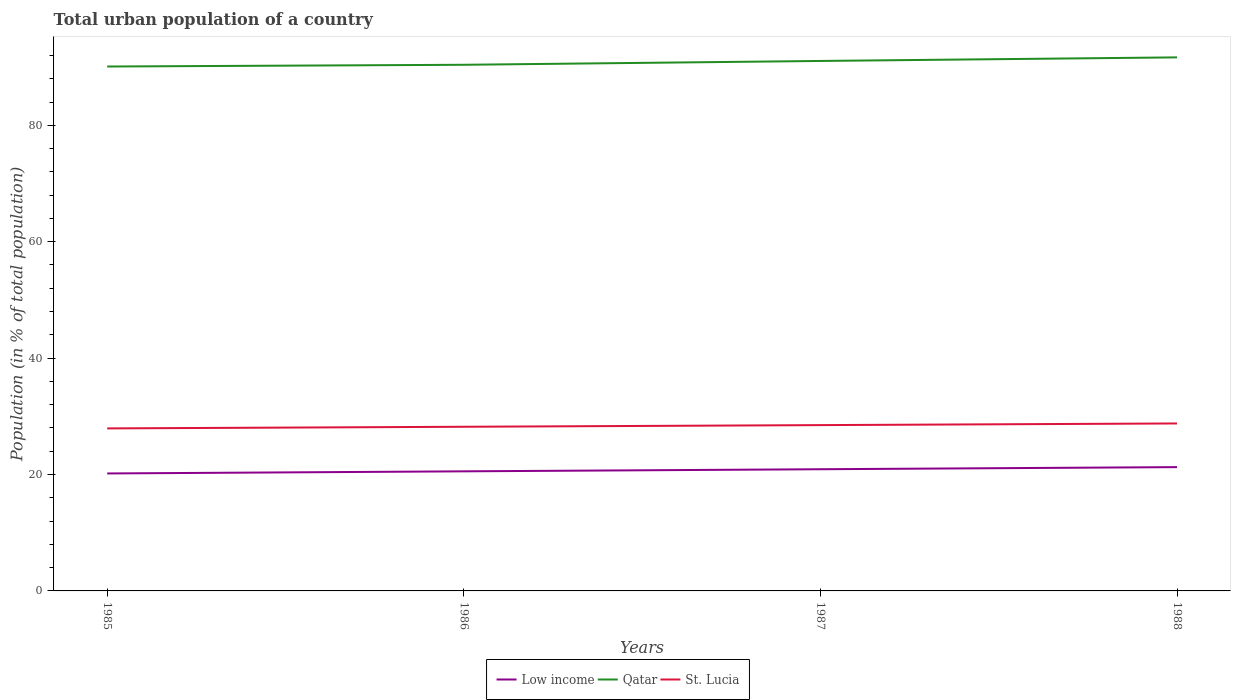Is the number of lines equal to the number of legend labels?
Offer a very short reply. Yes. Across all years, what is the maximum urban population in St. Lucia?
Ensure brevity in your answer.  27.92. What is the total urban population in St. Lucia in the graph?
Keep it short and to the point. -0.57. What is the difference between the highest and the second highest urban population in Qatar?
Keep it short and to the point. 1.57. Is the urban population in Low income strictly greater than the urban population in St. Lucia over the years?
Your answer should be very brief. Yes. How many lines are there?
Your answer should be very brief. 3. What is the difference between two consecutive major ticks on the Y-axis?
Provide a succinct answer. 20. Are the values on the major ticks of Y-axis written in scientific E-notation?
Keep it short and to the point. No. Does the graph contain any zero values?
Your answer should be very brief. No. Does the graph contain grids?
Make the answer very short. No. How many legend labels are there?
Give a very brief answer. 3. What is the title of the graph?
Offer a very short reply. Total urban population of a country. Does "St. Martin (French part)" appear as one of the legend labels in the graph?
Your answer should be very brief. No. What is the label or title of the X-axis?
Offer a very short reply. Years. What is the label or title of the Y-axis?
Provide a short and direct response. Population (in % of total population). What is the Population (in % of total population) of Low income in 1985?
Give a very brief answer. 20.18. What is the Population (in % of total population) of Qatar in 1985?
Your answer should be very brief. 90.1. What is the Population (in % of total population) of St. Lucia in 1985?
Keep it short and to the point. 27.92. What is the Population (in % of total population) of Low income in 1986?
Your response must be concise. 20.55. What is the Population (in % of total population) of Qatar in 1986?
Your answer should be compact. 90.4. What is the Population (in % of total population) in St. Lucia in 1986?
Provide a short and direct response. 28.2. What is the Population (in % of total population) in Low income in 1987?
Make the answer very short. 20.91. What is the Population (in % of total population) of Qatar in 1987?
Your response must be concise. 91.06. What is the Population (in % of total population) in St. Lucia in 1987?
Keep it short and to the point. 28.49. What is the Population (in % of total population) in Low income in 1988?
Offer a terse response. 21.27. What is the Population (in % of total population) in Qatar in 1988?
Offer a terse response. 91.67. What is the Population (in % of total population) in St. Lucia in 1988?
Your answer should be compact. 28.77. Across all years, what is the maximum Population (in % of total population) of Low income?
Make the answer very short. 21.27. Across all years, what is the maximum Population (in % of total population) of Qatar?
Provide a short and direct response. 91.67. Across all years, what is the maximum Population (in % of total population) of St. Lucia?
Provide a short and direct response. 28.77. Across all years, what is the minimum Population (in % of total population) of Low income?
Offer a terse response. 20.18. Across all years, what is the minimum Population (in % of total population) of Qatar?
Offer a terse response. 90.1. Across all years, what is the minimum Population (in % of total population) of St. Lucia?
Give a very brief answer. 27.92. What is the total Population (in % of total population) in Low income in the graph?
Make the answer very short. 82.91. What is the total Population (in % of total population) in Qatar in the graph?
Offer a very short reply. 363.23. What is the total Population (in % of total population) of St. Lucia in the graph?
Make the answer very short. 113.39. What is the difference between the Population (in % of total population) in Low income in 1985 and that in 1986?
Give a very brief answer. -0.37. What is the difference between the Population (in % of total population) in St. Lucia in 1985 and that in 1986?
Your answer should be very brief. -0.28. What is the difference between the Population (in % of total population) of Low income in 1985 and that in 1987?
Make the answer very short. -0.72. What is the difference between the Population (in % of total population) of Qatar in 1985 and that in 1987?
Offer a very short reply. -0.96. What is the difference between the Population (in % of total population) of St. Lucia in 1985 and that in 1987?
Ensure brevity in your answer.  -0.56. What is the difference between the Population (in % of total population) in Low income in 1985 and that in 1988?
Ensure brevity in your answer.  -1.09. What is the difference between the Population (in % of total population) of Qatar in 1985 and that in 1988?
Your answer should be very brief. -1.57. What is the difference between the Population (in % of total population) in St. Lucia in 1985 and that in 1988?
Offer a terse response. -0.85. What is the difference between the Population (in % of total population) of Low income in 1986 and that in 1987?
Ensure brevity in your answer.  -0.36. What is the difference between the Population (in % of total population) in Qatar in 1986 and that in 1987?
Your answer should be compact. -0.66. What is the difference between the Population (in % of total population) of St. Lucia in 1986 and that in 1987?
Your response must be concise. -0.28. What is the difference between the Population (in % of total population) in Low income in 1986 and that in 1988?
Give a very brief answer. -0.72. What is the difference between the Population (in % of total population) of Qatar in 1986 and that in 1988?
Your answer should be very brief. -1.27. What is the difference between the Population (in % of total population) in St. Lucia in 1986 and that in 1988?
Make the answer very short. -0.57. What is the difference between the Population (in % of total population) of Low income in 1987 and that in 1988?
Keep it short and to the point. -0.36. What is the difference between the Population (in % of total population) of Qatar in 1987 and that in 1988?
Offer a terse response. -0.61. What is the difference between the Population (in % of total population) in St. Lucia in 1987 and that in 1988?
Give a very brief answer. -0.29. What is the difference between the Population (in % of total population) of Low income in 1985 and the Population (in % of total population) of Qatar in 1986?
Keep it short and to the point. -70.22. What is the difference between the Population (in % of total population) in Low income in 1985 and the Population (in % of total population) in St. Lucia in 1986?
Your response must be concise. -8.02. What is the difference between the Population (in % of total population) of Qatar in 1985 and the Population (in % of total population) of St. Lucia in 1986?
Your answer should be compact. 61.9. What is the difference between the Population (in % of total population) of Low income in 1985 and the Population (in % of total population) of Qatar in 1987?
Provide a succinct answer. -70.87. What is the difference between the Population (in % of total population) in Low income in 1985 and the Population (in % of total population) in St. Lucia in 1987?
Provide a short and direct response. -8.31. What is the difference between the Population (in % of total population) in Qatar in 1985 and the Population (in % of total population) in St. Lucia in 1987?
Your answer should be very brief. 61.61. What is the difference between the Population (in % of total population) in Low income in 1985 and the Population (in % of total population) in Qatar in 1988?
Offer a very short reply. -71.49. What is the difference between the Population (in % of total population) of Low income in 1985 and the Population (in % of total population) of St. Lucia in 1988?
Offer a terse response. -8.59. What is the difference between the Population (in % of total population) of Qatar in 1985 and the Population (in % of total population) of St. Lucia in 1988?
Offer a very short reply. 61.33. What is the difference between the Population (in % of total population) of Low income in 1986 and the Population (in % of total population) of Qatar in 1987?
Offer a terse response. -70.51. What is the difference between the Population (in % of total population) of Low income in 1986 and the Population (in % of total population) of St. Lucia in 1987?
Ensure brevity in your answer.  -7.94. What is the difference between the Population (in % of total population) of Qatar in 1986 and the Population (in % of total population) of St. Lucia in 1987?
Provide a succinct answer. 61.91. What is the difference between the Population (in % of total population) in Low income in 1986 and the Population (in % of total population) in Qatar in 1988?
Provide a short and direct response. -71.12. What is the difference between the Population (in % of total population) in Low income in 1986 and the Population (in % of total population) in St. Lucia in 1988?
Your response must be concise. -8.23. What is the difference between the Population (in % of total population) of Qatar in 1986 and the Population (in % of total population) of St. Lucia in 1988?
Offer a very short reply. 61.63. What is the difference between the Population (in % of total population) of Low income in 1987 and the Population (in % of total population) of Qatar in 1988?
Offer a terse response. -70.76. What is the difference between the Population (in % of total population) in Low income in 1987 and the Population (in % of total population) in St. Lucia in 1988?
Give a very brief answer. -7.87. What is the difference between the Population (in % of total population) in Qatar in 1987 and the Population (in % of total population) in St. Lucia in 1988?
Your answer should be compact. 62.28. What is the average Population (in % of total population) in Low income per year?
Your answer should be compact. 20.73. What is the average Population (in % of total population) in Qatar per year?
Ensure brevity in your answer.  90.81. What is the average Population (in % of total population) of St. Lucia per year?
Keep it short and to the point. 28.35. In the year 1985, what is the difference between the Population (in % of total population) of Low income and Population (in % of total population) of Qatar?
Your response must be concise. -69.92. In the year 1985, what is the difference between the Population (in % of total population) in Low income and Population (in % of total population) in St. Lucia?
Your answer should be very brief. -7.74. In the year 1985, what is the difference between the Population (in % of total population) in Qatar and Population (in % of total population) in St. Lucia?
Make the answer very short. 62.18. In the year 1986, what is the difference between the Population (in % of total population) in Low income and Population (in % of total population) in Qatar?
Make the answer very short. -69.85. In the year 1986, what is the difference between the Population (in % of total population) of Low income and Population (in % of total population) of St. Lucia?
Offer a very short reply. -7.66. In the year 1986, what is the difference between the Population (in % of total population) in Qatar and Population (in % of total population) in St. Lucia?
Your answer should be compact. 62.2. In the year 1987, what is the difference between the Population (in % of total population) of Low income and Population (in % of total population) of Qatar?
Make the answer very short. -70.15. In the year 1987, what is the difference between the Population (in % of total population) in Low income and Population (in % of total population) in St. Lucia?
Offer a terse response. -7.58. In the year 1987, what is the difference between the Population (in % of total population) of Qatar and Population (in % of total population) of St. Lucia?
Give a very brief answer. 62.57. In the year 1988, what is the difference between the Population (in % of total population) in Low income and Population (in % of total population) in Qatar?
Make the answer very short. -70.4. In the year 1988, what is the difference between the Population (in % of total population) of Low income and Population (in % of total population) of St. Lucia?
Ensure brevity in your answer.  -7.5. In the year 1988, what is the difference between the Population (in % of total population) of Qatar and Population (in % of total population) of St. Lucia?
Keep it short and to the point. 62.9. What is the ratio of the Population (in % of total population) in Low income in 1985 to that in 1986?
Provide a succinct answer. 0.98. What is the ratio of the Population (in % of total population) in St. Lucia in 1985 to that in 1986?
Make the answer very short. 0.99. What is the ratio of the Population (in % of total population) in Low income in 1985 to that in 1987?
Offer a very short reply. 0.97. What is the ratio of the Population (in % of total population) in St. Lucia in 1985 to that in 1987?
Make the answer very short. 0.98. What is the ratio of the Population (in % of total population) of Low income in 1985 to that in 1988?
Make the answer very short. 0.95. What is the ratio of the Population (in % of total population) in Qatar in 1985 to that in 1988?
Provide a succinct answer. 0.98. What is the ratio of the Population (in % of total population) in St. Lucia in 1985 to that in 1988?
Provide a short and direct response. 0.97. What is the ratio of the Population (in % of total population) of Low income in 1986 to that in 1987?
Provide a succinct answer. 0.98. What is the ratio of the Population (in % of total population) of Qatar in 1986 to that in 1987?
Your answer should be compact. 0.99. What is the ratio of the Population (in % of total population) of St. Lucia in 1986 to that in 1987?
Your answer should be very brief. 0.99. What is the ratio of the Population (in % of total population) of Low income in 1986 to that in 1988?
Offer a terse response. 0.97. What is the ratio of the Population (in % of total population) in Qatar in 1986 to that in 1988?
Your answer should be very brief. 0.99. What is the ratio of the Population (in % of total population) in St. Lucia in 1986 to that in 1988?
Offer a very short reply. 0.98. What is the ratio of the Population (in % of total population) in Low income in 1987 to that in 1988?
Your response must be concise. 0.98. What is the ratio of the Population (in % of total population) in Qatar in 1987 to that in 1988?
Provide a succinct answer. 0.99. What is the difference between the highest and the second highest Population (in % of total population) of Low income?
Your response must be concise. 0.36. What is the difference between the highest and the second highest Population (in % of total population) of Qatar?
Make the answer very short. 0.61. What is the difference between the highest and the second highest Population (in % of total population) of St. Lucia?
Your response must be concise. 0.29. What is the difference between the highest and the lowest Population (in % of total population) of Low income?
Provide a short and direct response. 1.09. What is the difference between the highest and the lowest Population (in % of total population) of Qatar?
Your response must be concise. 1.57. What is the difference between the highest and the lowest Population (in % of total population) in St. Lucia?
Offer a terse response. 0.85. 